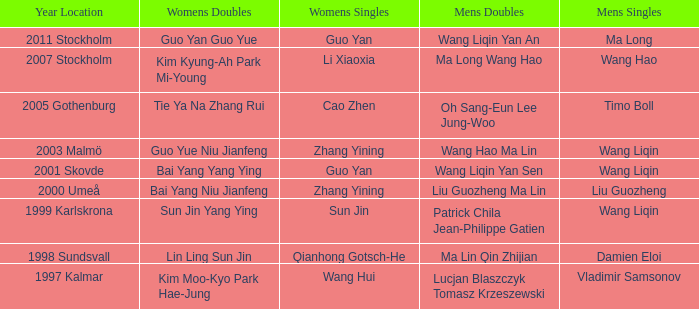How many times has Sun Jin won the women's doubles? 1.0. 